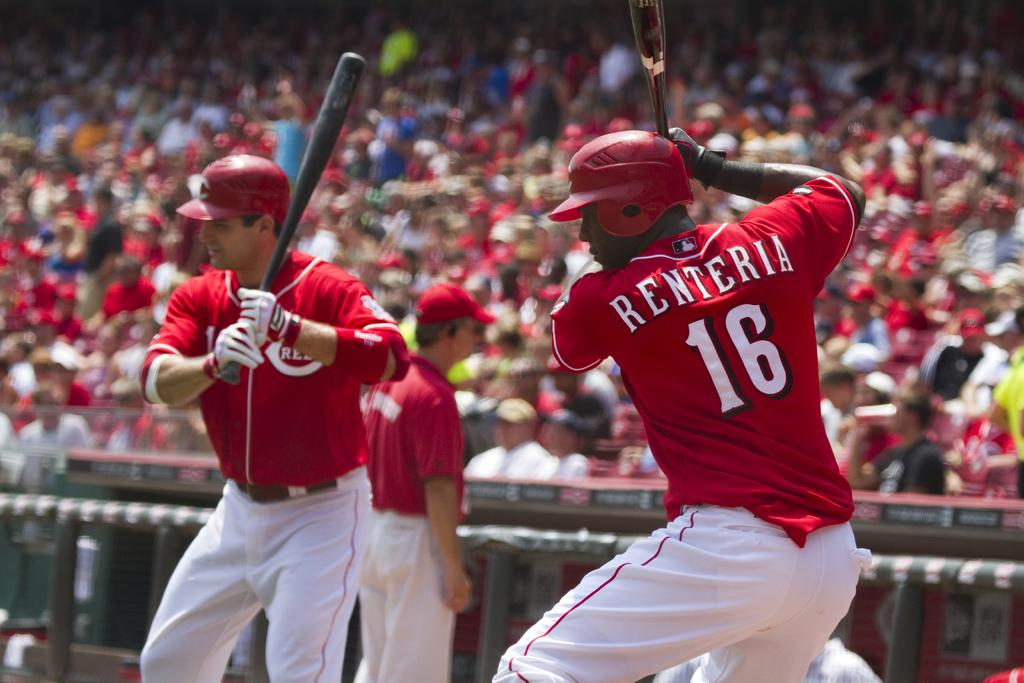Provide a one-sentence caption for the provided image. Two baseball players with bats, one with "Renteria 16" on his back. 